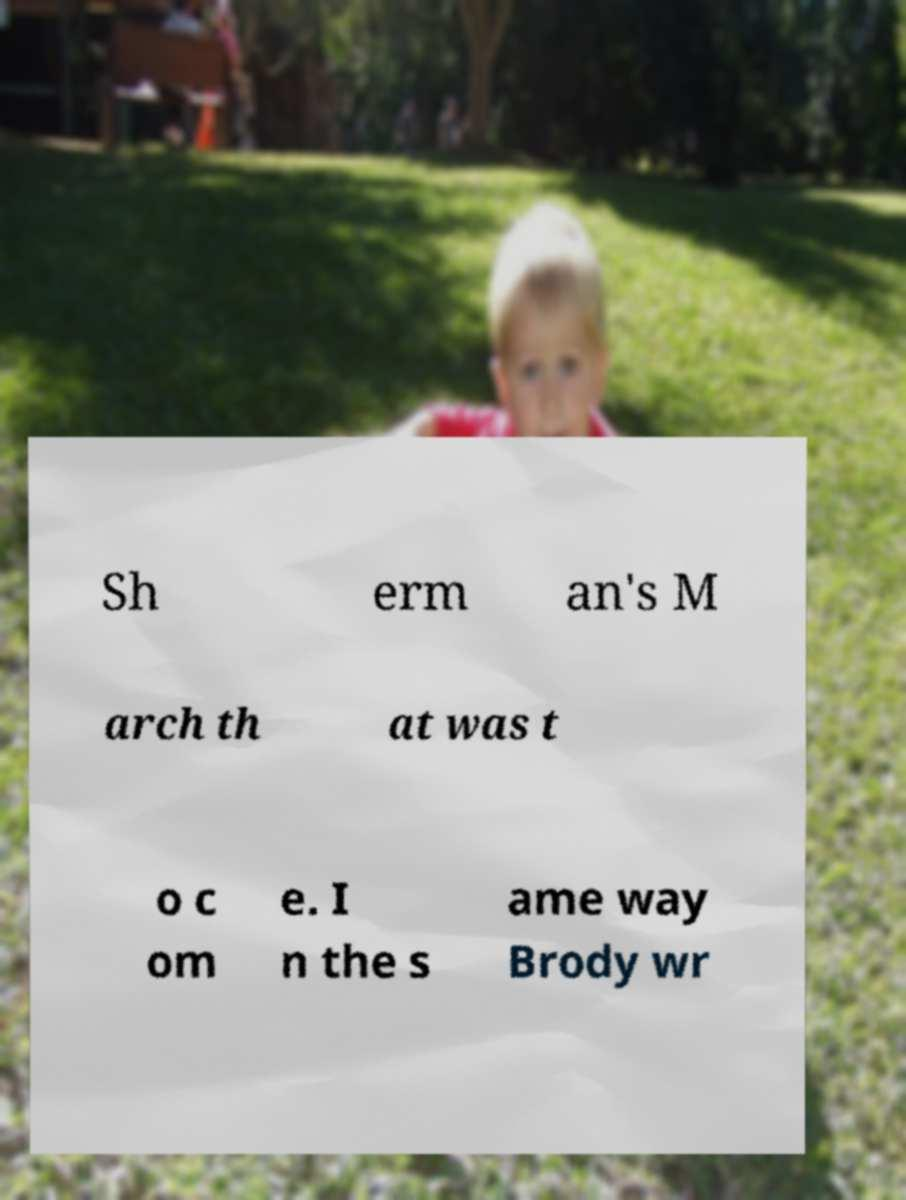Please identify and transcribe the text found in this image. Sh erm an's M arch th at was t o c om e. I n the s ame way Brody wr 